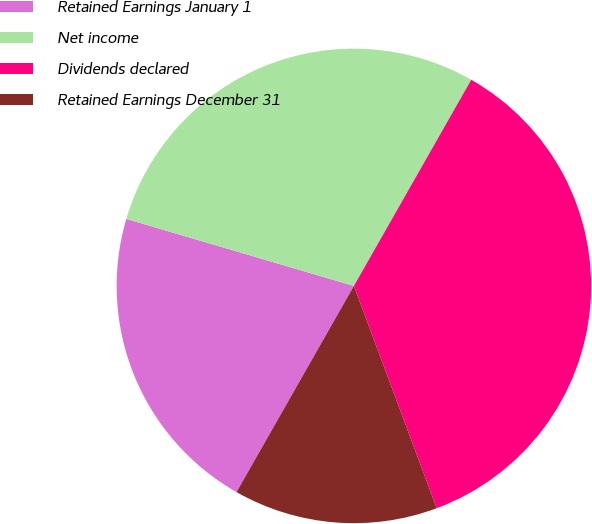<chart> <loc_0><loc_0><loc_500><loc_500><pie_chart><fcel>Retained Earnings January 1<fcel>Net income<fcel>Dividends declared<fcel>Retained Earnings December 31<nl><fcel>21.32%<fcel>28.68%<fcel>36.09%<fcel>13.91%<nl></chart> 